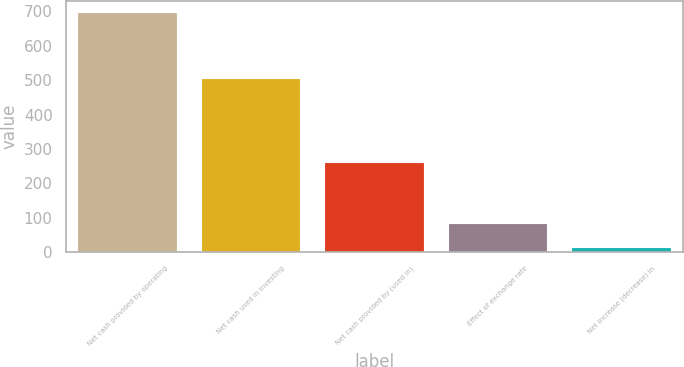Convert chart to OTSL. <chart><loc_0><loc_0><loc_500><loc_500><bar_chart><fcel>Net cash provided by operating<fcel>Net cash used in investing<fcel>Net cash provided by (used in)<fcel>Effect of exchange rate<fcel>Net increase (decrease) in<nl><fcel>695.4<fcel>505<fcel>260.5<fcel>80.7<fcel>12.4<nl></chart> 